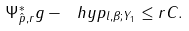Convert formula to latex. <formula><loc_0><loc_0><loc_500><loc_500>\| \Psi _ { \hat { p } , r } ^ { * } g - \ h y p \| _ { l , \beta ; Y _ { 1 } } \leq r C .</formula> 